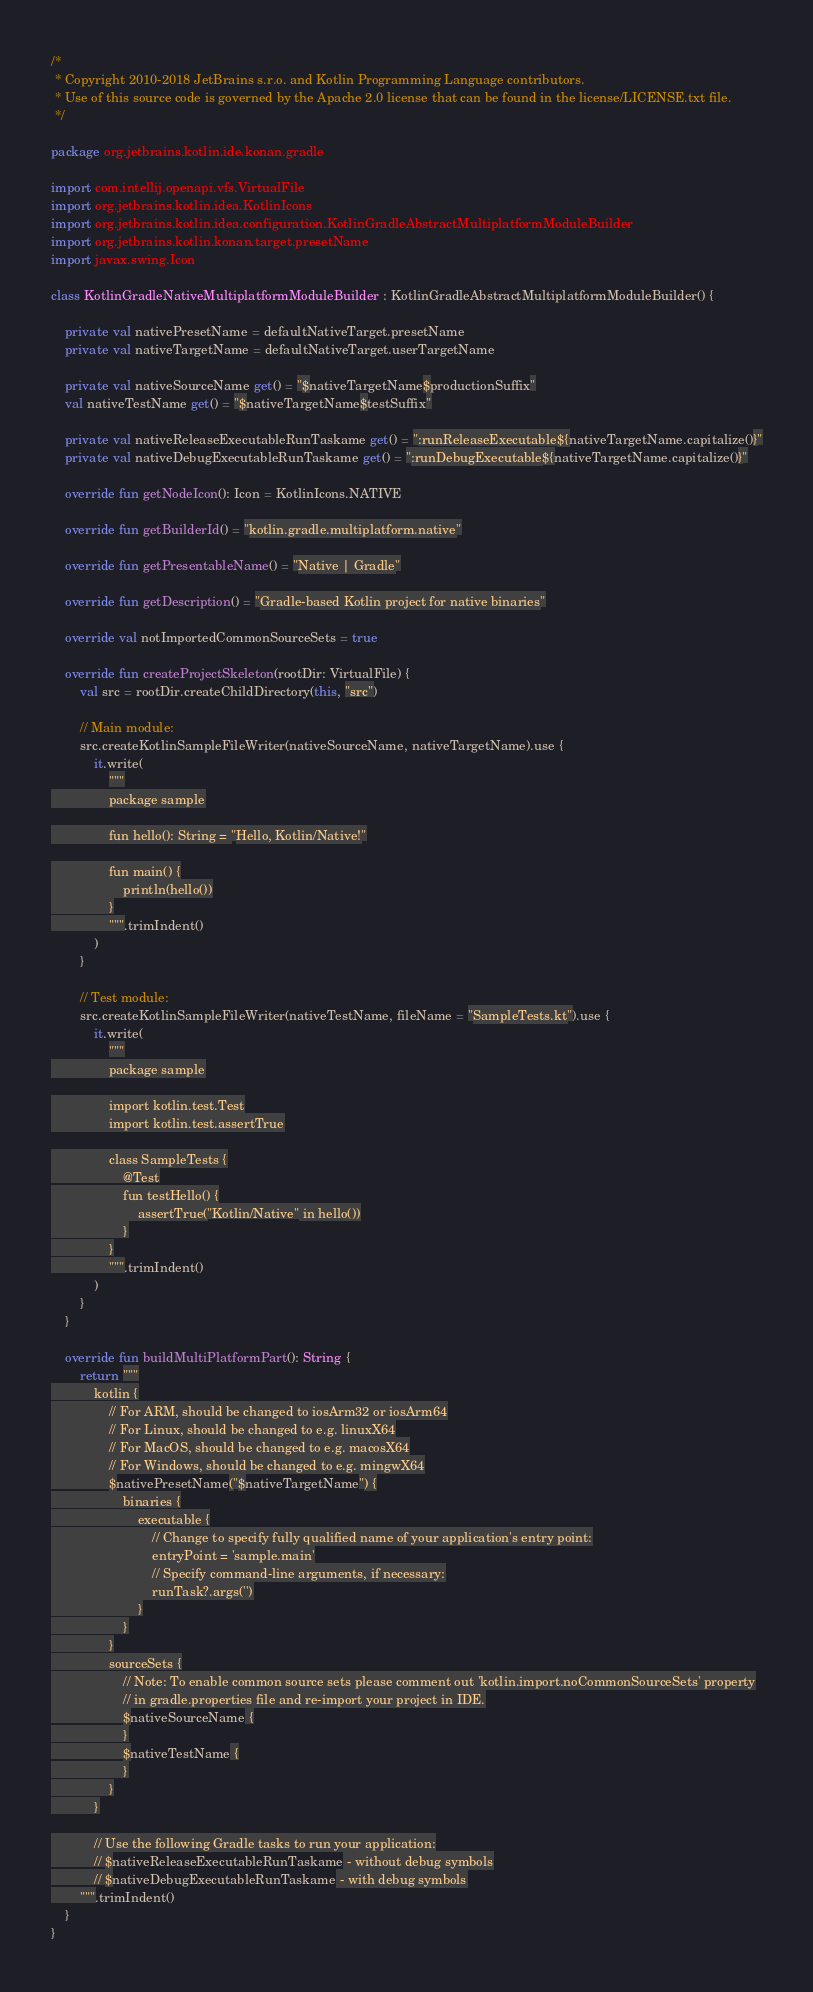<code> <loc_0><loc_0><loc_500><loc_500><_Kotlin_>/*
 * Copyright 2010-2018 JetBrains s.r.o. and Kotlin Programming Language contributors.
 * Use of this source code is governed by the Apache 2.0 license that can be found in the license/LICENSE.txt file.
 */

package org.jetbrains.kotlin.ide.konan.gradle

import com.intellij.openapi.vfs.VirtualFile
import org.jetbrains.kotlin.idea.KotlinIcons
import org.jetbrains.kotlin.idea.configuration.KotlinGradleAbstractMultiplatformModuleBuilder
import org.jetbrains.kotlin.konan.target.presetName
import javax.swing.Icon

class KotlinGradleNativeMultiplatformModuleBuilder : KotlinGradleAbstractMultiplatformModuleBuilder() {

    private val nativePresetName = defaultNativeTarget.presetName
    private val nativeTargetName = defaultNativeTarget.userTargetName

    private val nativeSourceName get() = "$nativeTargetName$productionSuffix"
    val nativeTestName get() = "$nativeTargetName$testSuffix"

    private val nativeReleaseExecutableRunTaskame get() = ":runReleaseExecutable${nativeTargetName.capitalize()}"
    private val nativeDebugExecutableRunTaskame get() = ":runDebugExecutable${nativeTargetName.capitalize()}"

    override fun getNodeIcon(): Icon = KotlinIcons.NATIVE

    override fun getBuilderId() = "kotlin.gradle.multiplatform.native"

    override fun getPresentableName() = "Native | Gradle"

    override fun getDescription() = "Gradle-based Kotlin project for native binaries"

    override val notImportedCommonSourceSets = true

    override fun createProjectSkeleton(rootDir: VirtualFile) {
        val src = rootDir.createChildDirectory(this, "src")

        // Main module:
        src.createKotlinSampleFileWriter(nativeSourceName, nativeTargetName).use {
            it.write(
                """
                package sample

                fun hello(): String = "Hello, Kotlin/Native!"

                fun main() {
                    println(hello())
                }
                """.trimIndent()
            )
        }

        // Test module:
        src.createKotlinSampleFileWriter(nativeTestName, fileName = "SampleTests.kt").use {
            it.write(
                """
                package sample

                import kotlin.test.Test
                import kotlin.test.assertTrue

                class SampleTests {
                    @Test
                    fun testHello() {
                        assertTrue("Kotlin/Native" in hello())
                    }
                }
                """.trimIndent()
            )
        }
    }

    override fun buildMultiPlatformPart(): String {
        return """
            kotlin {
                // For ARM, should be changed to iosArm32 or iosArm64
                // For Linux, should be changed to e.g. linuxX64
                // For MacOS, should be changed to e.g. macosX64
                // For Windows, should be changed to e.g. mingwX64
                $nativePresetName("$nativeTargetName") {
                    binaries {
                        executable {
                            // Change to specify fully qualified name of your application's entry point:
                            entryPoint = 'sample.main'
                            // Specify command-line arguments, if necessary:
                            runTask?.args('')
                        }
                    }
                }
                sourceSets {
                    // Note: To enable common source sets please comment out 'kotlin.import.noCommonSourceSets' property
                    // in gradle.properties file and re-import your project in IDE.
                    $nativeSourceName {
                    }
                    $nativeTestName {
                    }
                }
            }

            // Use the following Gradle tasks to run your application:
            // $nativeReleaseExecutableRunTaskame - without debug symbols
            // $nativeDebugExecutableRunTaskame - with debug symbols
        """.trimIndent()
    }
}
</code> 